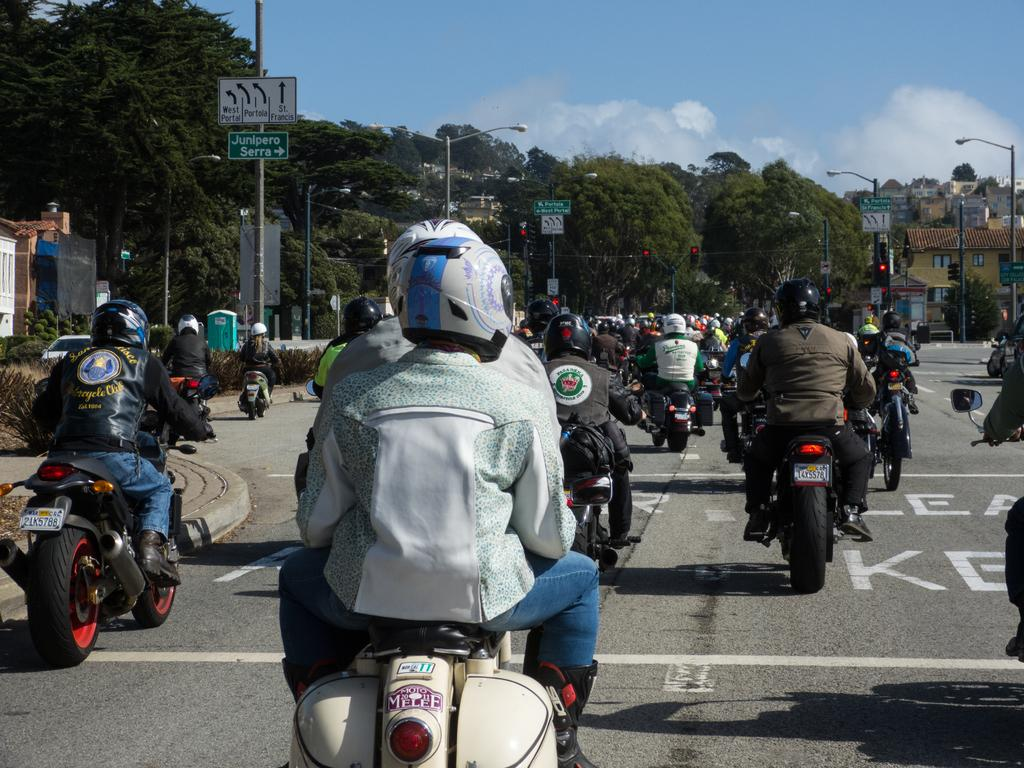How many people are in the image? There is a group of persons in the image. What are the persons doing in the image? The persons are riding motorcycles. What can be seen in the background of the image? There are trees and the sky in the background of the image. What is the condition of the sky in the image? The sky is clear and visible in the background of the image. What degree of difficulty is the railway track in the image? There is no railway track present in the image. How many lifts are visible in the image? There are no lifts visible in the image. 